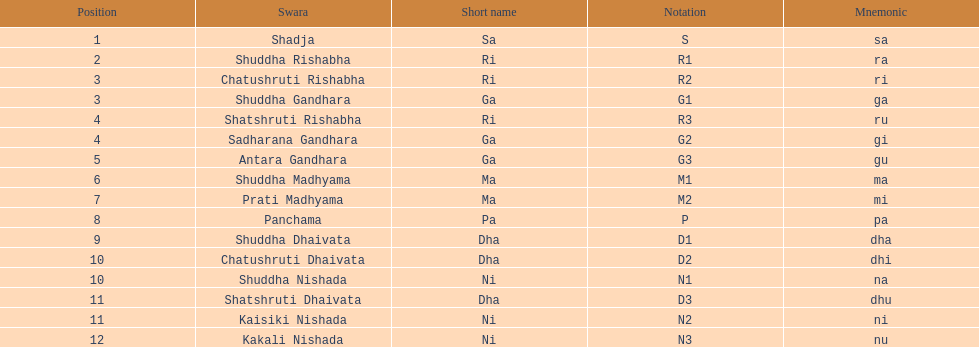Which swara can be found in the last place? Kakali Nishada. 